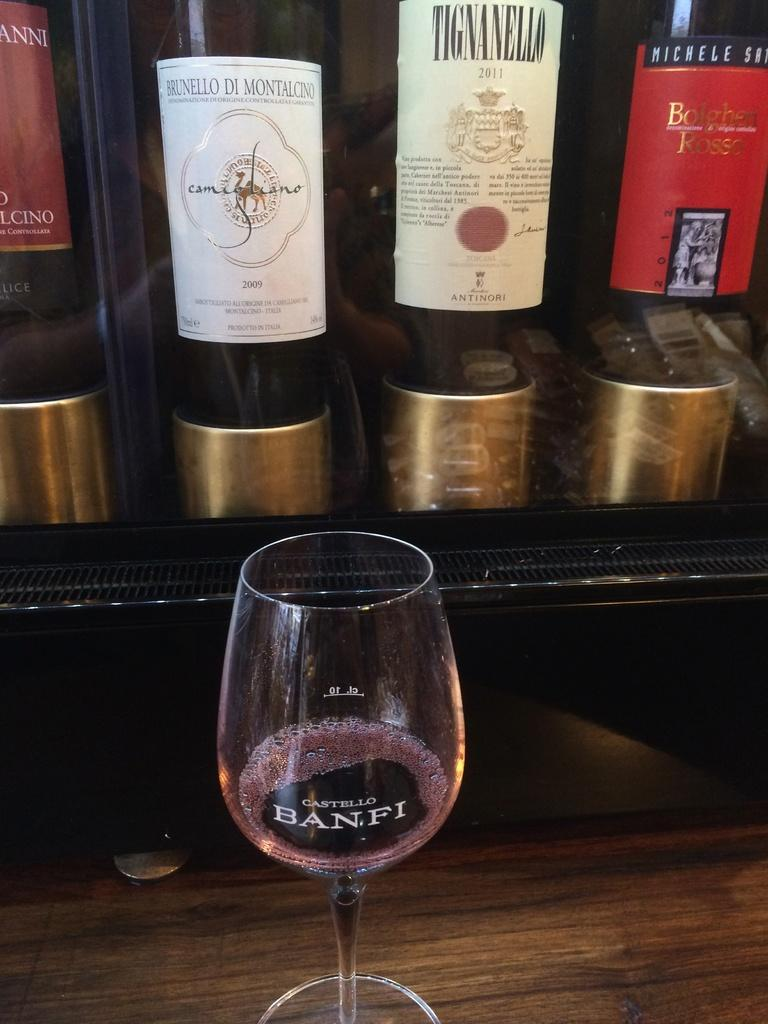<image>
Provide a brief description of the given image. Empty wine glass which says BANFI on the front. 